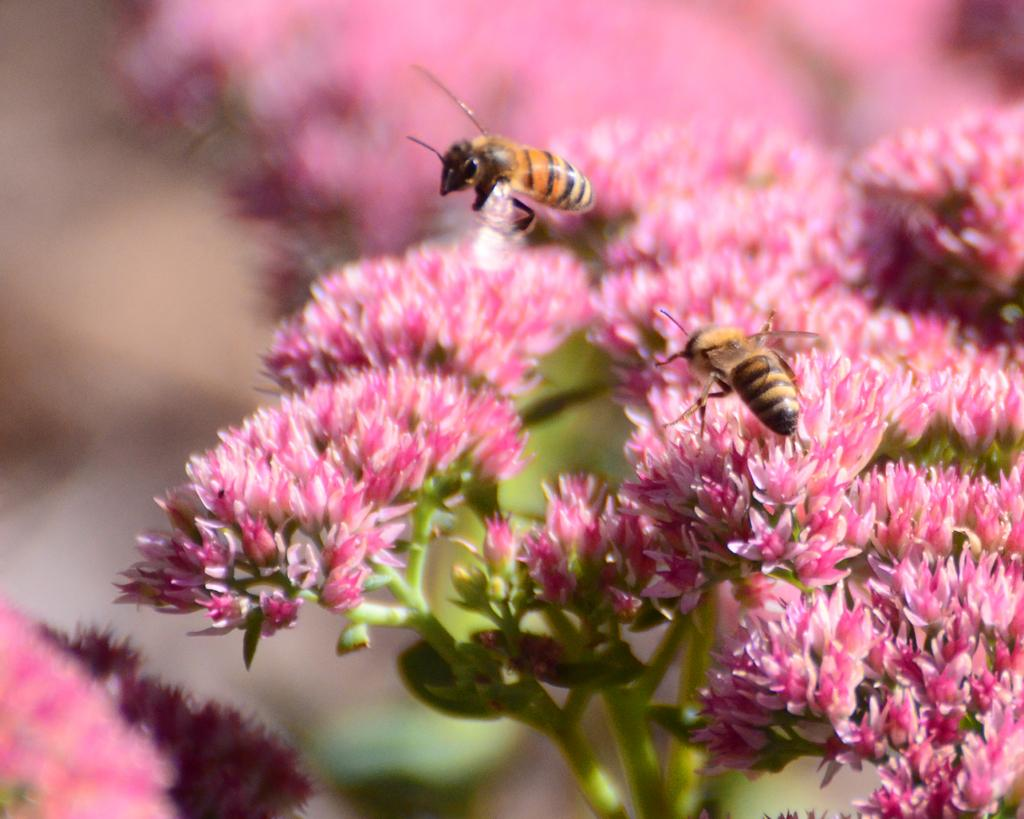What is present in the image? There are flowers in the image. Can you describe the insects in the image? There is an insect on a flower, and another insect is in the air. How is the background of the image depicted? The background of the image is blurred. Despite the blur, what can still be seen in the background? Flowers are visible in the background. What type of chin can be seen on the flower in the image? There is no chin present in the image, as it features flowers and insects. Is there a volleyball being played in the image? There is no volleyball or any indication of a game being played in the image. 